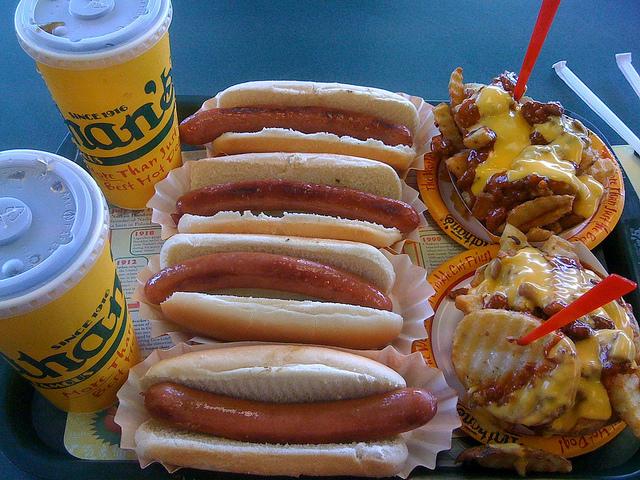What is covered in cheese?
Be succinct. Fries. What kind of drinks are on the table?
Keep it brief. Soda. Is this healthy food?
Answer briefly. No. 